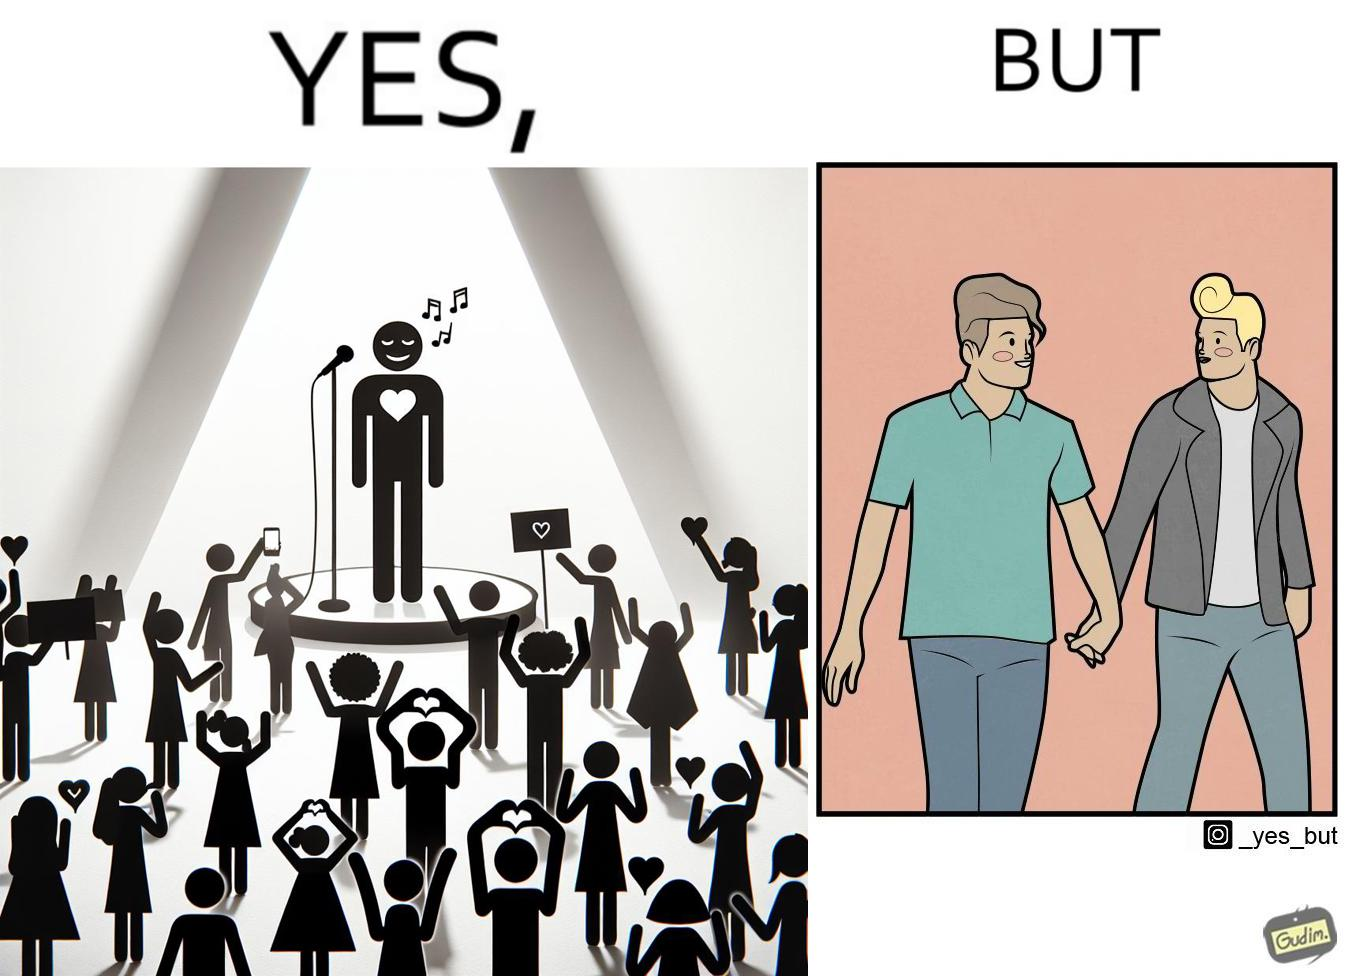What do you see in each half of this image? In the left part of the image: The person shows a man singing on a platform under a spotlight. There are several girls around the platform enjoying his singing and cheering for him. A few girls are taking his photos using their phone and a few also have a poster with heart drawn on it. In the right part of the image: The image shows two men holding hands. 